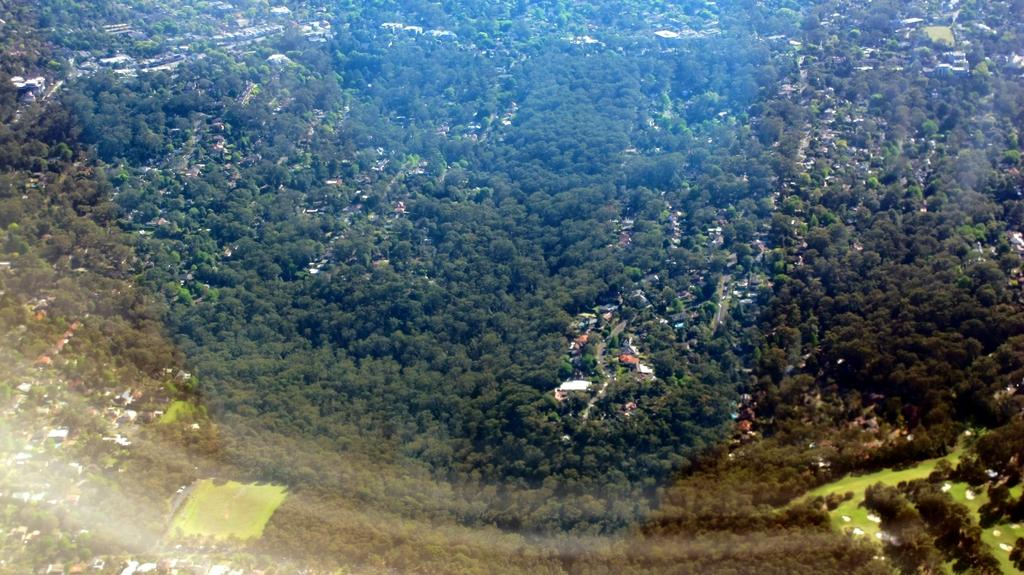What type of view is shown in the image? The image is an aerial view. What natural elements can be seen in the image? There are trees visible in the image. What man-made structures can be seen in the image? There are buildings visible in the image. What type of transportation might be present in the image? Vehicles are present in the image. How does the image demonstrate an increase in arithmetic skills? The image does not demonstrate an increase in arithmetic skills, as it is a photograph and not related to mathematical concepts. What type of cake is being served in the image? There is no cake present in the image; it features an aerial view of a landscape with trees and buildings. 